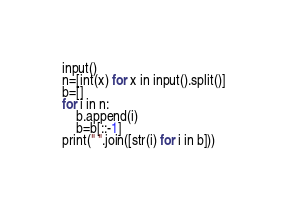Convert code to text. <code><loc_0><loc_0><loc_500><loc_500><_Python_>input()
n=[int(x) for x in input().split()]
b=[]
for i in n:
    b.append(i)
    b=b[::-1]
print(" ".join([str(i) for i in b]))</code> 